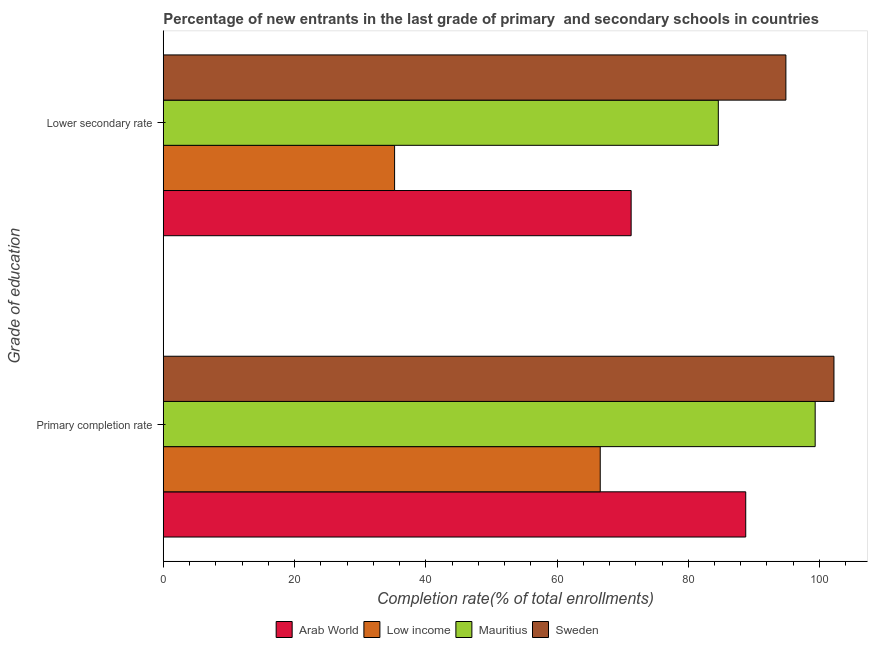Are the number of bars per tick equal to the number of legend labels?
Your answer should be compact. Yes. Are the number of bars on each tick of the Y-axis equal?
Your response must be concise. Yes. How many bars are there on the 1st tick from the top?
Your answer should be very brief. 4. How many bars are there on the 1st tick from the bottom?
Your response must be concise. 4. What is the label of the 2nd group of bars from the top?
Make the answer very short. Primary completion rate. What is the completion rate in secondary schools in Mauritius?
Ensure brevity in your answer.  84.58. Across all countries, what is the maximum completion rate in primary schools?
Make the answer very short. 102.2. Across all countries, what is the minimum completion rate in secondary schools?
Your response must be concise. 35.25. In which country was the completion rate in secondary schools maximum?
Provide a short and direct response. Sweden. What is the total completion rate in secondary schools in the graph?
Ensure brevity in your answer.  286.01. What is the difference between the completion rate in primary schools in Sweden and that in Mauritius?
Offer a very short reply. 2.86. What is the difference between the completion rate in secondary schools in Low income and the completion rate in primary schools in Mauritius?
Keep it short and to the point. -64.09. What is the average completion rate in primary schools per country?
Ensure brevity in your answer.  89.22. What is the difference between the completion rate in secondary schools and completion rate in primary schools in Low income?
Ensure brevity in your answer.  -31.34. In how many countries, is the completion rate in secondary schools greater than 8 %?
Offer a terse response. 4. What is the ratio of the completion rate in secondary schools in Low income to that in Arab World?
Offer a terse response. 0.49. Is the completion rate in primary schools in Mauritius less than that in Sweden?
Keep it short and to the point. Yes. In how many countries, is the completion rate in primary schools greater than the average completion rate in primary schools taken over all countries?
Provide a short and direct response. 2. What does the 4th bar from the top in Lower secondary rate represents?
Your response must be concise. Arab World. What does the 3rd bar from the bottom in Primary completion rate represents?
Make the answer very short. Mauritius. How many bars are there?
Ensure brevity in your answer.  8. How many countries are there in the graph?
Ensure brevity in your answer.  4. Does the graph contain any zero values?
Your answer should be very brief. No. Does the graph contain grids?
Keep it short and to the point. No. Where does the legend appear in the graph?
Make the answer very short. Bottom center. How many legend labels are there?
Make the answer very short. 4. What is the title of the graph?
Give a very brief answer. Percentage of new entrants in the last grade of primary  and secondary schools in countries. What is the label or title of the X-axis?
Your answer should be compact. Completion rate(% of total enrollments). What is the label or title of the Y-axis?
Ensure brevity in your answer.  Grade of education. What is the Completion rate(% of total enrollments) in Arab World in Primary completion rate?
Ensure brevity in your answer.  88.76. What is the Completion rate(% of total enrollments) in Low income in Primary completion rate?
Offer a terse response. 66.59. What is the Completion rate(% of total enrollments) of Mauritius in Primary completion rate?
Provide a succinct answer. 99.34. What is the Completion rate(% of total enrollments) in Sweden in Primary completion rate?
Your answer should be compact. 102.2. What is the Completion rate(% of total enrollments) in Arab World in Lower secondary rate?
Keep it short and to the point. 71.3. What is the Completion rate(% of total enrollments) of Low income in Lower secondary rate?
Make the answer very short. 35.25. What is the Completion rate(% of total enrollments) in Mauritius in Lower secondary rate?
Make the answer very short. 84.58. What is the Completion rate(% of total enrollments) in Sweden in Lower secondary rate?
Give a very brief answer. 94.88. Across all Grade of education, what is the maximum Completion rate(% of total enrollments) of Arab World?
Give a very brief answer. 88.76. Across all Grade of education, what is the maximum Completion rate(% of total enrollments) in Low income?
Your answer should be compact. 66.59. Across all Grade of education, what is the maximum Completion rate(% of total enrollments) of Mauritius?
Provide a short and direct response. 99.34. Across all Grade of education, what is the maximum Completion rate(% of total enrollments) of Sweden?
Your answer should be compact. 102.2. Across all Grade of education, what is the minimum Completion rate(% of total enrollments) in Arab World?
Provide a succinct answer. 71.3. Across all Grade of education, what is the minimum Completion rate(% of total enrollments) of Low income?
Make the answer very short. 35.25. Across all Grade of education, what is the minimum Completion rate(% of total enrollments) of Mauritius?
Your response must be concise. 84.58. Across all Grade of education, what is the minimum Completion rate(% of total enrollments) of Sweden?
Your answer should be very brief. 94.88. What is the total Completion rate(% of total enrollments) of Arab World in the graph?
Keep it short and to the point. 160.06. What is the total Completion rate(% of total enrollments) of Low income in the graph?
Provide a succinct answer. 101.84. What is the total Completion rate(% of total enrollments) of Mauritius in the graph?
Make the answer very short. 183.93. What is the total Completion rate(% of total enrollments) in Sweden in the graph?
Keep it short and to the point. 197.08. What is the difference between the Completion rate(% of total enrollments) of Arab World in Primary completion rate and that in Lower secondary rate?
Offer a very short reply. 17.46. What is the difference between the Completion rate(% of total enrollments) in Low income in Primary completion rate and that in Lower secondary rate?
Provide a succinct answer. 31.34. What is the difference between the Completion rate(% of total enrollments) in Mauritius in Primary completion rate and that in Lower secondary rate?
Offer a very short reply. 14.76. What is the difference between the Completion rate(% of total enrollments) in Sweden in Primary completion rate and that in Lower secondary rate?
Provide a succinct answer. 7.33. What is the difference between the Completion rate(% of total enrollments) in Arab World in Primary completion rate and the Completion rate(% of total enrollments) in Low income in Lower secondary rate?
Ensure brevity in your answer.  53.51. What is the difference between the Completion rate(% of total enrollments) of Arab World in Primary completion rate and the Completion rate(% of total enrollments) of Mauritius in Lower secondary rate?
Your response must be concise. 4.18. What is the difference between the Completion rate(% of total enrollments) of Arab World in Primary completion rate and the Completion rate(% of total enrollments) of Sweden in Lower secondary rate?
Provide a succinct answer. -6.12. What is the difference between the Completion rate(% of total enrollments) of Low income in Primary completion rate and the Completion rate(% of total enrollments) of Mauritius in Lower secondary rate?
Offer a terse response. -17.99. What is the difference between the Completion rate(% of total enrollments) in Low income in Primary completion rate and the Completion rate(% of total enrollments) in Sweden in Lower secondary rate?
Give a very brief answer. -28.29. What is the difference between the Completion rate(% of total enrollments) in Mauritius in Primary completion rate and the Completion rate(% of total enrollments) in Sweden in Lower secondary rate?
Your response must be concise. 4.46. What is the average Completion rate(% of total enrollments) in Arab World per Grade of education?
Make the answer very short. 80.03. What is the average Completion rate(% of total enrollments) of Low income per Grade of education?
Your answer should be very brief. 50.92. What is the average Completion rate(% of total enrollments) of Mauritius per Grade of education?
Give a very brief answer. 91.96. What is the average Completion rate(% of total enrollments) in Sweden per Grade of education?
Offer a very short reply. 98.54. What is the difference between the Completion rate(% of total enrollments) of Arab World and Completion rate(% of total enrollments) of Low income in Primary completion rate?
Your answer should be very brief. 22.17. What is the difference between the Completion rate(% of total enrollments) of Arab World and Completion rate(% of total enrollments) of Mauritius in Primary completion rate?
Ensure brevity in your answer.  -10.58. What is the difference between the Completion rate(% of total enrollments) of Arab World and Completion rate(% of total enrollments) of Sweden in Primary completion rate?
Your answer should be compact. -13.45. What is the difference between the Completion rate(% of total enrollments) in Low income and Completion rate(% of total enrollments) in Mauritius in Primary completion rate?
Your answer should be compact. -32.76. What is the difference between the Completion rate(% of total enrollments) in Low income and Completion rate(% of total enrollments) in Sweden in Primary completion rate?
Provide a short and direct response. -35.62. What is the difference between the Completion rate(% of total enrollments) of Mauritius and Completion rate(% of total enrollments) of Sweden in Primary completion rate?
Make the answer very short. -2.86. What is the difference between the Completion rate(% of total enrollments) of Arab World and Completion rate(% of total enrollments) of Low income in Lower secondary rate?
Keep it short and to the point. 36.05. What is the difference between the Completion rate(% of total enrollments) in Arab World and Completion rate(% of total enrollments) in Mauritius in Lower secondary rate?
Give a very brief answer. -13.28. What is the difference between the Completion rate(% of total enrollments) in Arab World and Completion rate(% of total enrollments) in Sweden in Lower secondary rate?
Make the answer very short. -23.58. What is the difference between the Completion rate(% of total enrollments) of Low income and Completion rate(% of total enrollments) of Mauritius in Lower secondary rate?
Provide a short and direct response. -49.33. What is the difference between the Completion rate(% of total enrollments) of Low income and Completion rate(% of total enrollments) of Sweden in Lower secondary rate?
Offer a very short reply. -59.63. What is the difference between the Completion rate(% of total enrollments) in Mauritius and Completion rate(% of total enrollments) in Sweden in Lower secondary rate?
Ensure brevity in your answer.  -10.3. What is the ratio of the Completion rate(% of total enrollments) in Arab World in Primary completion rate to that in Lower secondary rate?
Keep it short and to the point. 1.24. What is the ratio of the Completion rate(% of total enrollments) of Low income in Primary completion rate to that in Lower secondary rate?
Keep it short and to the point. 1.89. What is the ratio of the Completion rate(% of total enrollments) in Mauritius in Primary completion rate to that in Lower secondary rate?
Give a very brief answer. 1.17. What is the ratio of the Completion rate(% of total enrollments) of Sweden in Primary completion rate to that in Lower secondary rate?
Offer a terse response. 1.08. What is the difference between the highest and the second highest Completion rate(% of total enrollments) of Arab World?
Make the answer very short. 17.46. What is the difference between the highest and the second highest Completion rate(% of total enrollments) in Low income?
Offer a very short reply. 31.34. What is the difference between the highest and the second highest Completion rate(% of total enrollments) of Mauritius?
Provide a short and direct response. 14.76. What is the difference between the highest and the second highest Completion rate(% of total enrollments) in Sweden?
Your answer should be compact. 7.33. What is the difference between the highest and the lowest Completion rate(% of total enrollments) in Arab World?
Give a very brief answer. 17.46. What is the difference between the highest and the lowest Completion rate(% of total enrollments) of Low income?
Offer a terse response. 31.34. What is the difference between the highest and the lowest Completion rate(% of total enrollments) in Mauritius?
Keep it short and to the point. 14.76. What is the difference between the highest and the lowest Completion rate(% of total enrollments) of Sweden?
Offer a very short reply. 7.33. 